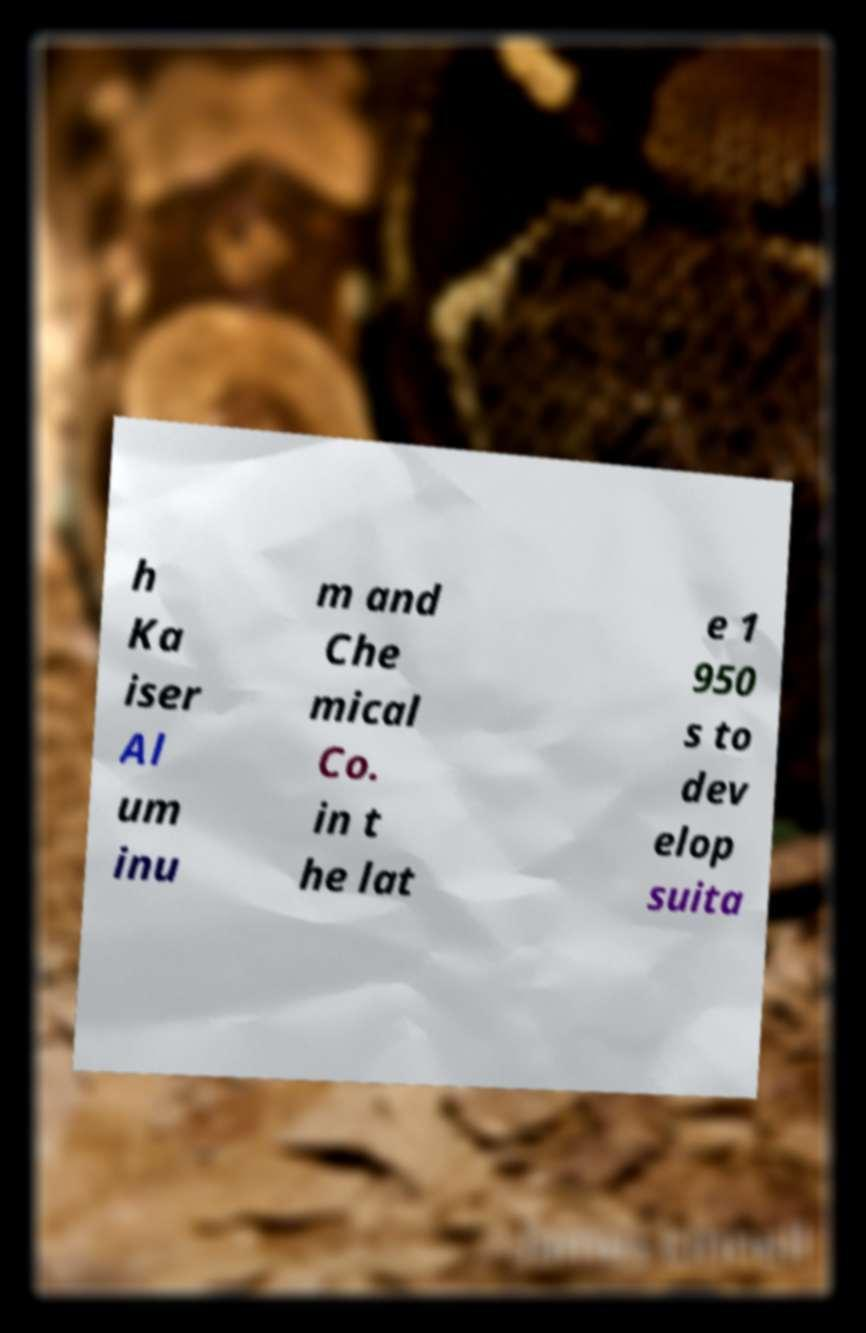Please identify and transcribe the text found in this image. h Ka iser Al um inu m and Che mical Co. in t he lat e 1 950 s to dev elop suita 